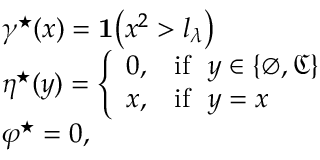<formula> <loc_0><loc_0><loc_500><loc_500>\begin{array} { r l } & { \gamma ^ { ^ { * } } ( x ) = 1 \left ( x ^ { 2 } > l _ { \lambda } \right ) } \\ & { \eta ^ { ^ { * } } ( y ) = \left \{ \begin{array} { l l } { 0 , } & { i f \ \ y \in \{ \varnothing , \mathfrak { C } \} } \\ { x , } & { i f \ \ y = x } \end{array} } \\ & { \varphi ^ { ^ { * } } = 0 , } \end{array}</formula> 